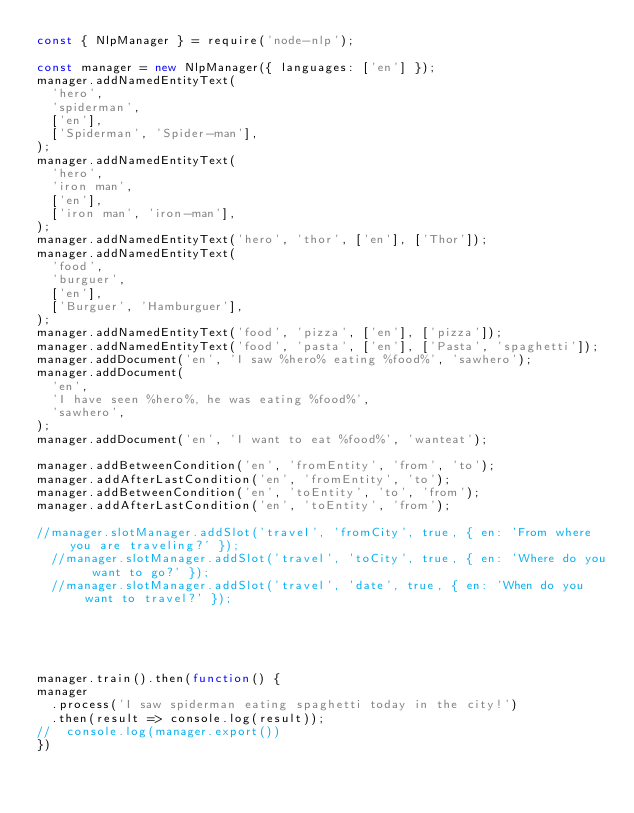<code> <loc_0><loc_0><loc_500><loc_500><_JavaScript_>const { NlpManager } = require('node-nlp');

const manager = new NlpManager({ languages: ['en'] });
manager.addNamedEntityText(
  'hero',
  'spiderman',
  ['en'],
  ['Spiderman', 'Spider-man'],
);
manager.addNamedEntityText(
  'hero',
  'iron man',
  ['en'],
  ['iron man', 'iron-man'],
);
manager.addNamedEntityText('hero', 'thor', ['en'], ['Thor']);
manager.addNamedEntityText(
  'food',
  'burguer',
  ['en'],
  ['Burguer', 'Hamburguer'],
);
manager.addNamedEntityText('food', 'pizza', ['en'], ['pizza']);
manager.addNamedEntityText('food', 'pasta', ['en'], ['Pasta', 'spaghetti']);
manager.addDocument('en', 'I saw %hero% eating %food%', 'sawhero');
manager.addDocument(
  'en',
  'I have seen %hero%, he was eating %food%',
  'sawhero',
);
manager.addDocument('en', 'I want to eat %food%', 'wanteat');

manager.addBetweenCondition('en', 'fromEntity', 'from', 'to');
manager.addAfterLastCondition('en', 'fromEntity', 'to');
manager.addBetweenCondition('en', 'toEntity', 'to', 'from');
manager.addAfterLastCondition('en', 'toEntity', 'from');

//manager.slotManager.addSlot('travel', 'fromCity', true, { en: 'From where you are traveling?' });
  //manager.slotManager.addSlot('travel', 'toCity', true, { en: 'Where do you want to go?' });
  //manager.slotManager.addSlot('travel', 'date', true, { en: 'When do you want to travel?' });
  
  
  


manager.train().then(function() {
manager
  .process('I saw spiderman eating spaghetti today in the city!')
  .then(result => console.log(result));
//  console.log(manager.export())
})
</code> 